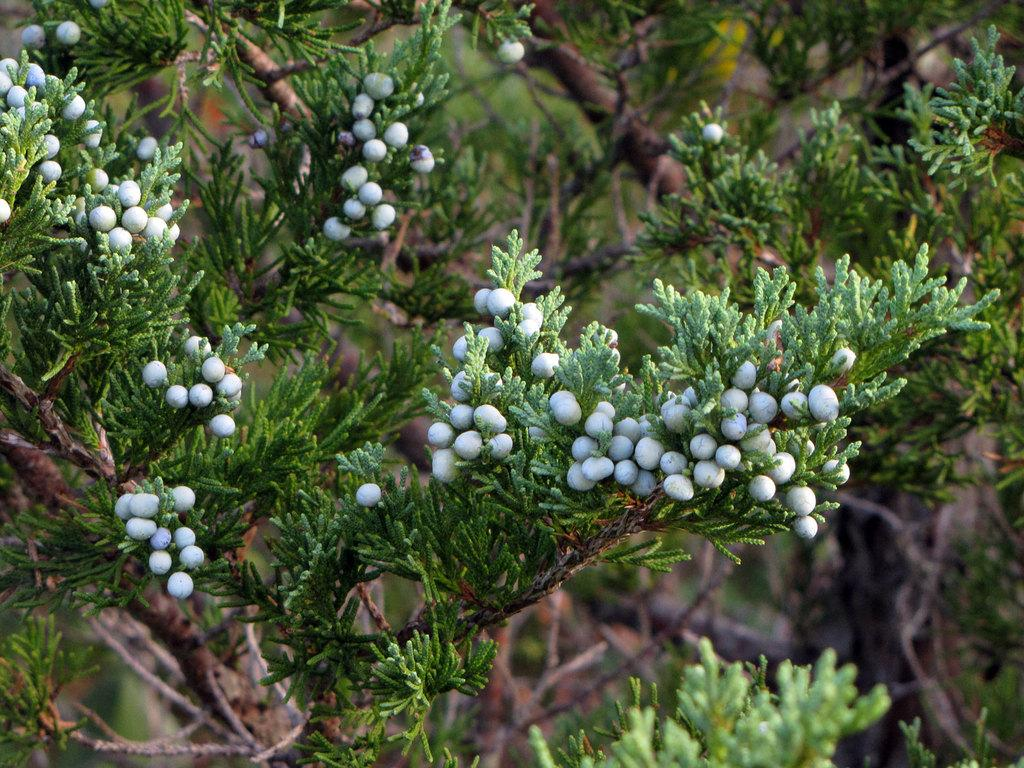What type of animals are in the image? There are white color birds in the image. Where are the birds located? The birds are on a tree. What is the color of the leaves on the tree? The leaves on the tree are green. How does the digestion process of the girls in the image work? There are no girls present in the image, only white color birds on a tree with green leaves. 